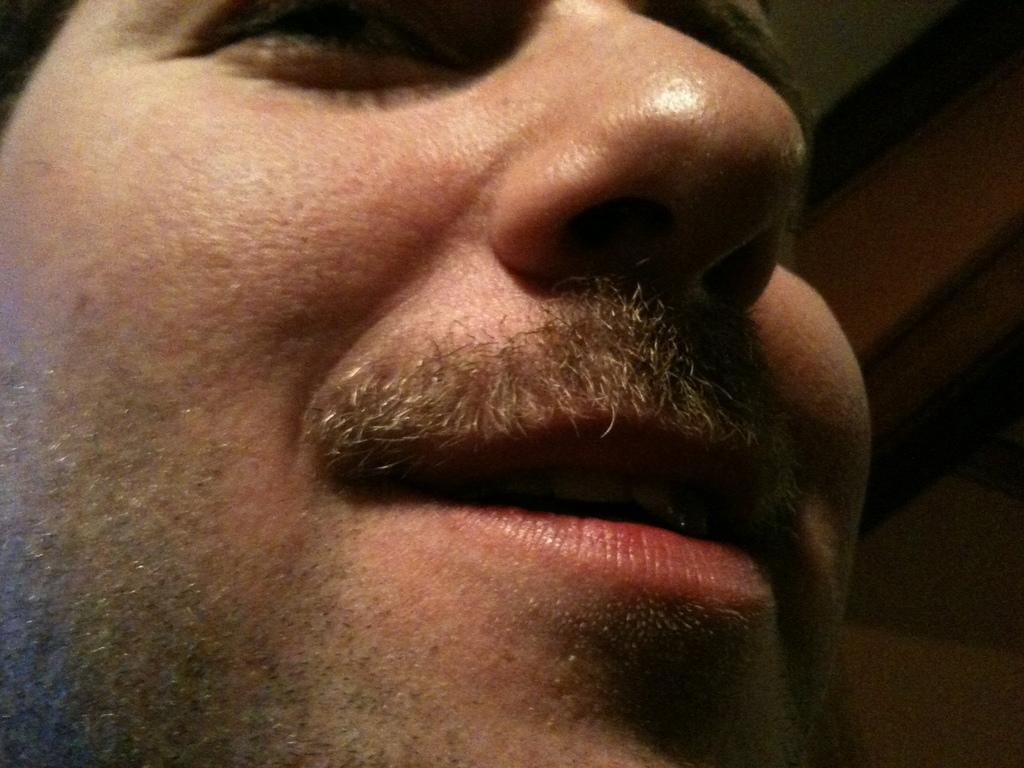What is the main subject of the image? There is a man's face in the image. What facial features can be seen in the image? The man's eye, nose, and mouth are visible in the image. What is the color of the right side of the image? The right side of the image is black in color. What type of silk fabric is draped over the man's face in the image? There is no silk fabric present in the image; it features a man's face with visible facial features. 